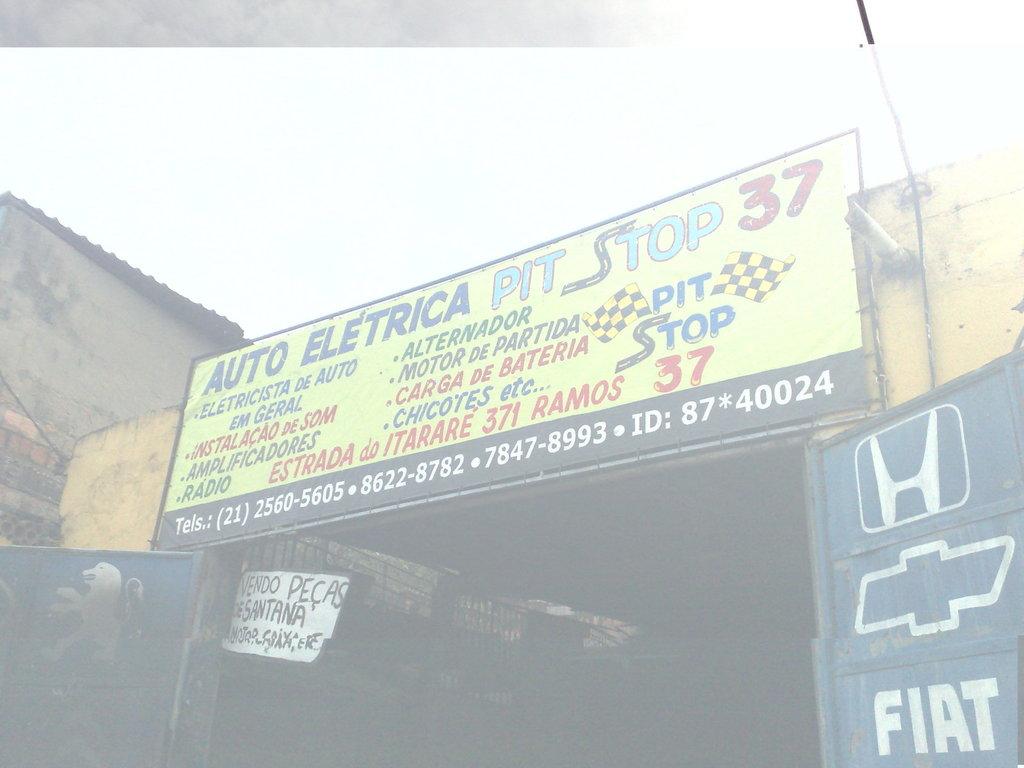What three letter winery is displayed in the middle?
Keep it short and to the point. Unanswerable. 